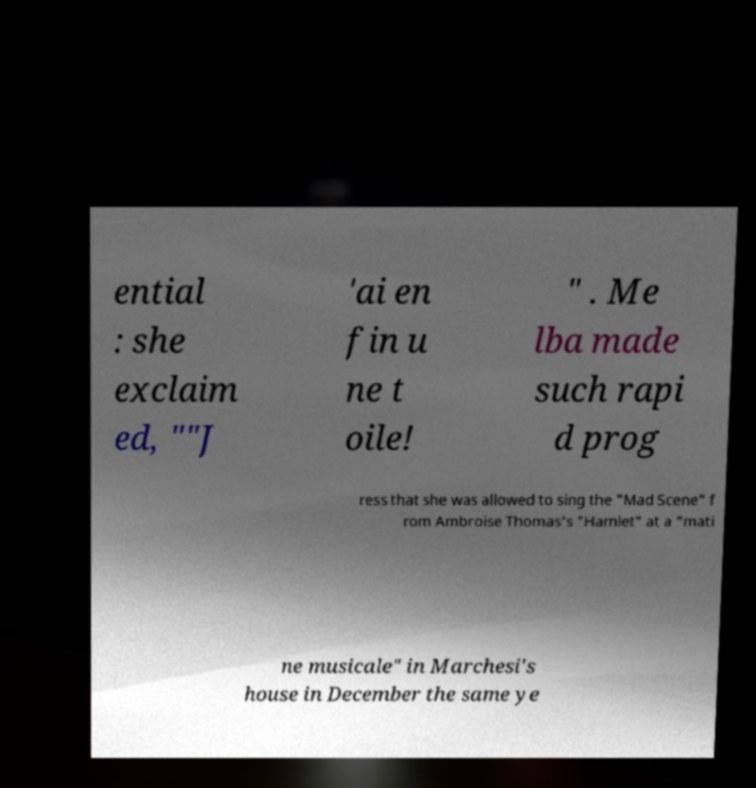For documentation purposes, I need the text within this image transcribed. Could you provide that? ential : she exclaim ed, ""J 'ai en fin u ne t oile! " . Me lba made such rapi d prog ress that she was allowed to sing the "Mad Scene" f rom Ambroise Thomas's "Hamlet" at a "mati ne musicale" in Marchesi's house in December the same ye 